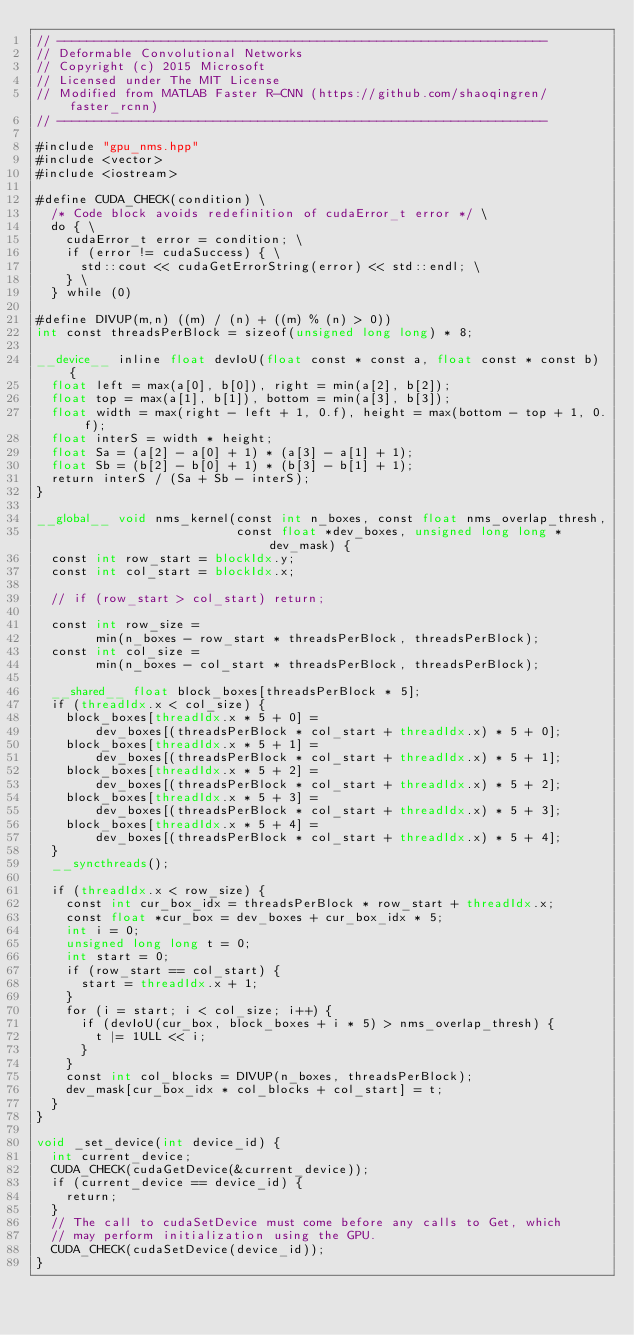<code> <loc_0><loc_0><loc_500><loc_500><_Cuda_>// ------------------------------------------------------------------
// Deformable Convolutional Networks
// Copyright (c) 2015 Microsoft
// Licensed under The MIT License
// Modified from MATLAB Faster R-CNN (https://github.com/shaoqingren/faster_rcnn)
// ------------------------------------------------------------------

#include "gpu_nms.hpp"
#include <vector>
#include <iostream>

#define CUDA_CHECK(condition) \
  /* Code block avoids redefinition of cudaError_t error */ \
  do { \
    cudaError_t error = condition; \
    if (error != cudaSuccess) { \
      std::cout << cudaGetErrorString(error) << std::endl; \
    } \
  } while (0)

#define DIVUP(m,n) ((m) / (n) + ((m) % (n) > 0))
int const threadsPerBlock = sizeof(unsigned long long) * 8;

__device__ inline float devIoU(float const * const a, float const * const b) {
  float left = max(a[0], b[0]), right = min(a[2], b[2]);
  float top = max(a[1], b[1]), bottom = min(a[3], b[3]);
  float width = max(right - left + 1, 0.f), height = max(bottom - top + 1, 0.f);
  float interS = width * height;
  float Sa = (a[2] - a[0] + 1) * (a[3] - a[1] + 1);
  float Sb = (b[2] - b[0] + 1) * (b[3] - b[1] + 1);
  return interS / (Sa + Sb - interS);
}

__global__ void nms_kernel(const int n_boxes, const float nms_overlap_thresh,
                           const float *dev_boxes, unsigned long long *dev_mask) {
  const int row_start = blockIdx.y;
  const int col_start = blockIdx.x;

  // if (row_start > col_start) return;

  const int row_size =
        min(n_boxes - row_start * threadsPerBlock, threadsPerBlock);
  const int col_size =
        min(n_boxes - col_start * threadsPerBlock, threadsPerBlock);

  __shared__ float block_boxes[threadsPerBlock * 5];
  if (threadIdx.x < col_size) {
    block_boxes[threadIdx.x * 5 + 0] =
        dev_boxes[(threadsPerBlock * col_start + threadIdx.x) * 5 + 0];
    block_boxes[threadIdx.x * 5 + 1] =
        dev_boxes[(threadsPerBlock * col_start + threadIdx.x) * 5 + 1];
    block_boxes[threadIdx.x * 5 + 2] =
        dev_boxes[(threadsPerBlock * col_start + threadIdx.x) * 5 + 2];
    block_boxes[threadIdx.x * 5 + 3] =
        dev_boxes[(threadsPerBlock * col_start + threadIdx.x) * 5 + 3];
    block_boxes[threadIdx.x * 5 + 4] =
        dev_boxes[(threadsPerBlock * col_start + threadIdx.x) * 5 + 4];
  }
  __syncthreads();

  if (threadIdx.x < row_size) {
    const int cur_box_idx = threadsPerBlock * row_start + threadIdx.x;
    const float *cur_box = dev_boxes + cur_box_idx * 5;
    int i = 0;
    unsigned long long t = 0;
    int start = 0;
    if (row_start == col_start) {
      start = threadIdx.x + 1;
    }
    for (i = start; i < col_size; i++) {
      if (devIoU(cur_box, block_boxes + i * 5) > nms_overlap_thresh) {
        t |= 1ULL << i;
      }
    }
    const int col_blocks = DIVUP(n_boxes, threadsPerBlock);
    dev_mask[cur_box_idx * col_blocks + col_start] = t;
  }
}

void _set_device(int device_id) {
  int current_device;
  CUDA_CHECK(cudaGetDevice(&current_device));
  if (current_device == device_id) {
    return;
  }
  // The call to cudaSetDevice must come before any calls to Get, which
  // may perform initialization using the GPU.
  CUDA_CHECK(cudaSetDevice(device_id));
}
</code> 